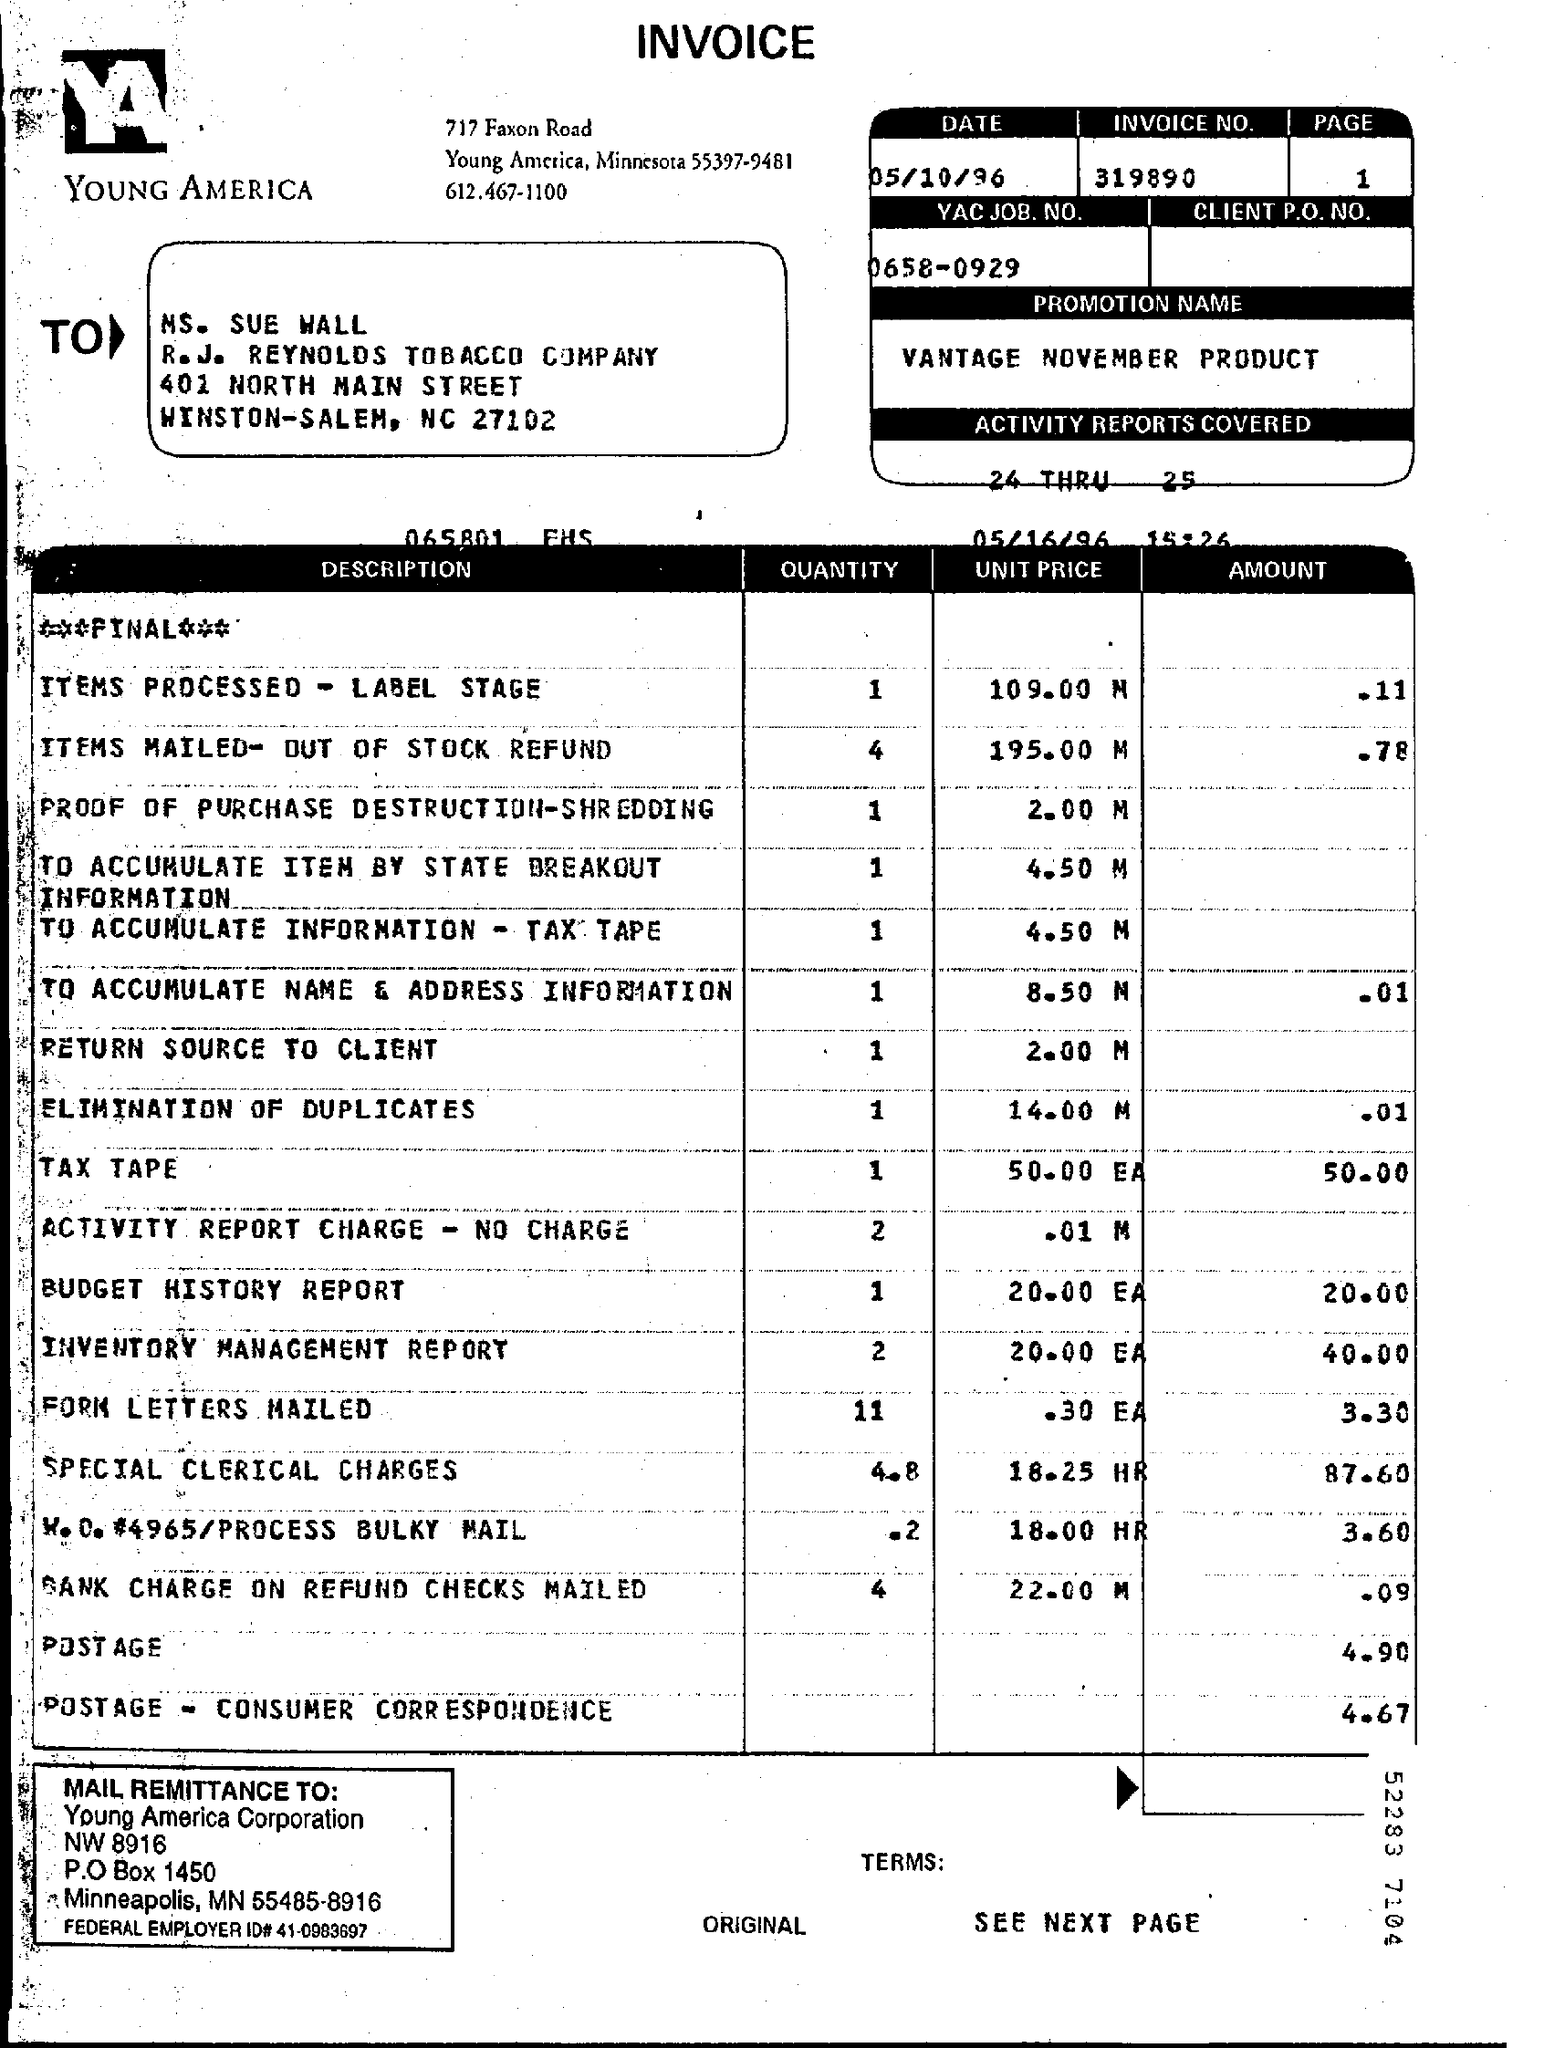Highlight a few significant elements in this photo. The invoice number is 319890... The promotion name is Vantage November Product Promotion. 